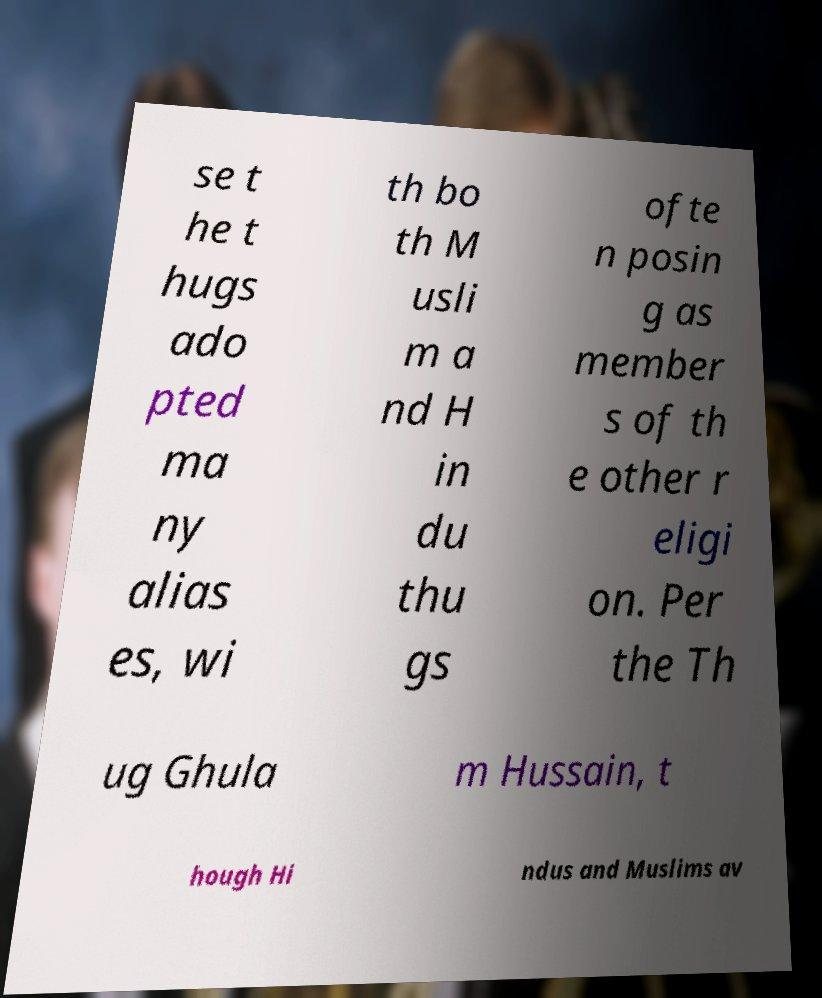Could you extract and type out the text from this image? se t he t hugs ado pted ma ny alias es, wi th bo th M usli m a nd H in du thu gs ofte n posin g as member s of th e other r eligi on. Per the Th ug Ghula m Hussain, t hough Hi ndus and Muslims av 